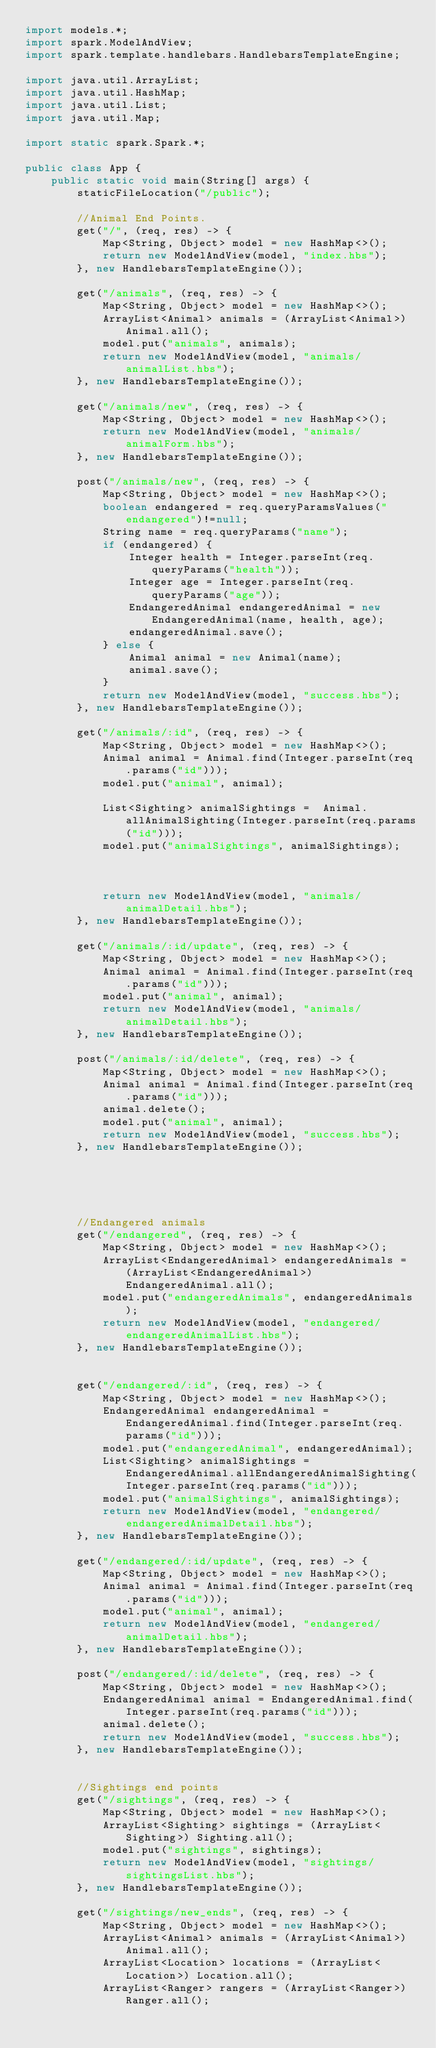<code> <loc_0><loc_0><loc_500><loc_500><_Java_>import models.*;
import spark.ModelAndView;
import spark.template.handlebars.HandlebarsTemplateEngine;

import java.util.ArrayList;
import java.util.HashMap;
import java.util.List;
import java.util.Map;

import static spark.Spark.*;

public class App {
    public static void main(String[] args) {
        staticFileLocation("/public");

        //Animal End Points.
        get("/", (req, res) -> {
            Map<String, Object> model = new HashMap<>();
            return new ModelAndView(model, "index.hbs");
        }, new HandlebarsTemplateEngine());

        get("/animals", (req, res) -> {
            Map<String, Object> model = new HashMap<>();
            ArrayList<Animal> animals = (ArrayList<Animal>) Animal.all();
            model.put("animals", animals);
            return new ModelAndView(model, "animals/animalList.hbs");
        }, new HandlebarsTemplateEngine());

        get("/animals/new", (req, res) -> {
            Map<String, Object> model = new HashMap<>();
            return new ModelAndView(model, "animals/animalForm.hbs");
        }, new HandlebarsTemplateEngine());

        post("/animals/new", (req, res) -> {
            Map<String, Object> model = new HashMap<>();
            boolean endangered = req.queryParamsValues("endangered")!=null;
            String name = req.queryParams("name");
            if (endangered) {
                Integer health = Integer.parseInt(req.queryParams("health"));
                Integer age = Integer.parseInt(req.queryParams("age"));
                EndangeredAnimal endangeredAnimal = new EndangeredAnimal(name, health, age);
                endangeredAnimal.save();
            } else {
                Animal animal = new Animal(name);
                animal.save();
            }
            return new ModelAndView(model, "success.hbs");
        }, new HandlebarsTemplateEngine());

        get("/animals/:id", (req, res) -> {
            Map<String, Object> model = new HashMap<>();
            Animal animal = Animal.find(Integer.parseInt(req.params("id")));
            model.put("animal", animal);

            List<Sighting> animalSightings =  Animal.allAnimalSighting(Integer.parseInt(req.params("id")));
            model.put("animalSightings", animalSightings);



            return new ModelAndView(model, "animals/animalDetail.hbs");
        }, new HandlebarsTemplateEngine());

        get("/animals/:id/update", (req, res) -> {
            Map<String, Object> model = new HashMap<>();
            Animal animal = Animal.find(Integer.parseInt(req.params("id")));
            model.put("animal", animal);
            return new ModelAndView(model, "animals/animalDetail.hbs");
        }, new HandlebarsTemplateEngine());

        post("/animals/:id/delete", (req, res) -> {
            Map<String, Object> model = new HashMap<>();
            Animal animal = Animal.find(Integer.parseInt(req.params("id")));
            animal.delete();
            model.put("animal", animal);
            return new ModelAndView(model, "success.hbs");
        }, new HandlebarsTemplateEngine());





        //Endangered animals
        get("/endangered", (req, res) -> {
            Map<String, Object> model = new HashMap<>();
            ArrayList<EndangeredAnimal> endangeredAnimals = (ArrayList<EndangeredAnimal>) EndangeredAnimal.all();
            model.put("endangeredAnimals", endangeredAnimals);
            return new ModelAndView(model, "endangered/endangeredAnimalList.hbs");
        }, new HandlebarsTemplateEngine());


        get("/endangered/:id", (req, res) -> {
            Map<String, Object> model = new HashMap<>();
            EndangeredAnimal endangeredAnimal = EndangeredAnimal.find(Integer.parseInt(req.params("id")));
            model.put("endangeredAnimal", endangeredAnimal);
            List<Sighting> animalSightings =  EndangeredAnimal.allEndangeredAnimalSighting(Integer.parseInt(req.params("id")));
            model.put("animalSightings", animalSightings);
            return new ModelAndView(model, "endangered/endangeredAnimalDetail.hbs");
        }, new HandlebarsTemplateEngine());

        get("/endangered/:id/update", (req, res) -> {
            Map<String, Object> model = new HashMap<>();
            Animal animal = Animal.find(Integer.parseInt(req.params("id")));
            model.put("animal", animal);
            return new ModelAndView(model, "endangered/animalDetail.hbs");
        }, new HandlebarsTemplateEngine());

        post("/endangered/:id/delete", (req, res) -> {
            Map<String, Object> model = new HashMap<>();
            EndangeredAnimal animal = EndangeredAnimal.find(Integer.parseInt(req.params("id")));
            animal.delete();
            return new ModelAndView(model, "success.hbs");
        }, new HandlebarsTemplateEngine());


        //Sightings end points
        get("/sightings", (req, res) -> {
            Map<String, Object> model = new HashMap<>();
            ArrayList<Sighting> sightings = (ArrayList<Sighting>) Sighting.all();
            model.put("sightings", sightings);
            return new ModelAndView(model, "sightings/sightingsList.hbs");
        }, new HandlebarsTemplateEngine());

        get("/sightings/new_ends", (req, res) -> {
            Map<String, Object> model = new HashMap<>();
            ArrayList<Animal> animals = (ArrayList<Animal>) Animal.all();
            ArrayList<Location> locations = (ArrayList<Location>) Location.all();
            ArrayList<Ranger> rangers = (ArrayList<Ranger>) Ranger.all();</code> 